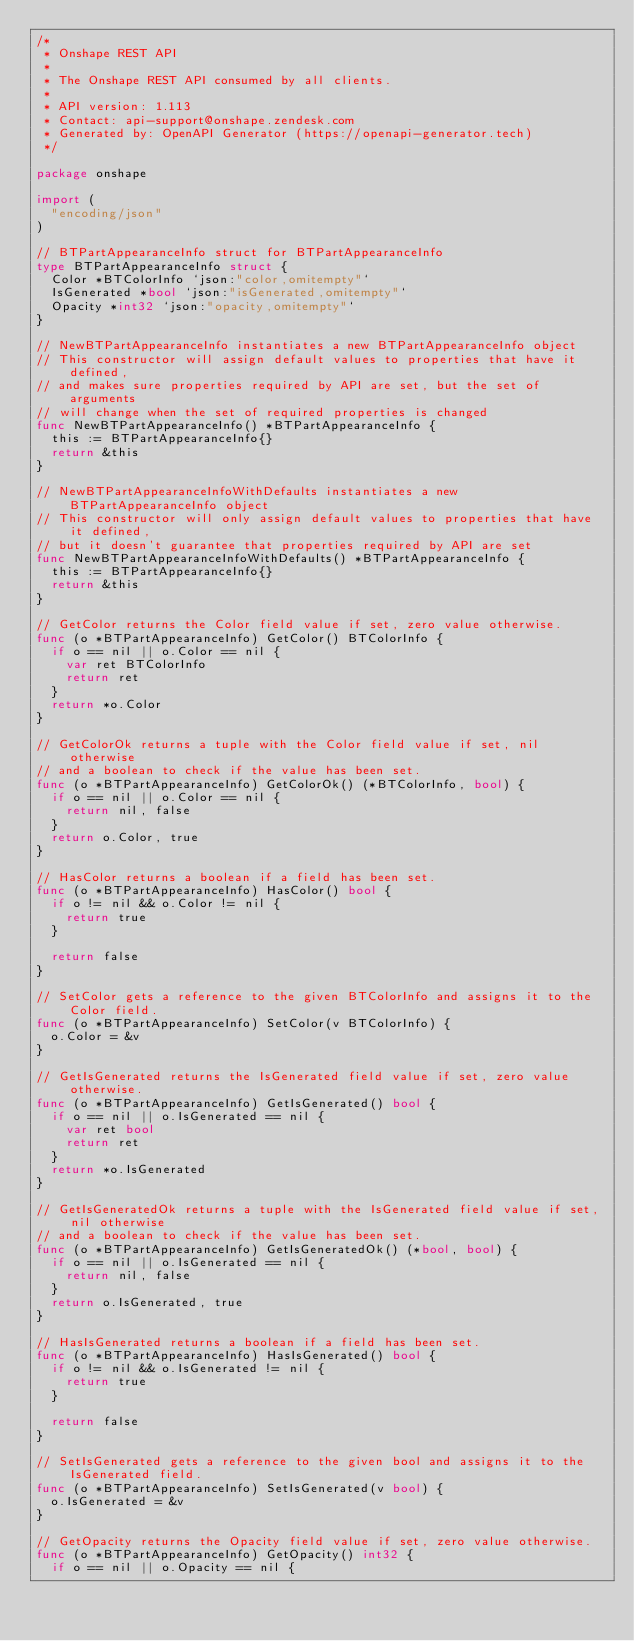<code> <loc_0><loc_0><loc_500><loc_500><_Go_>/*
 * Onshape REST API
 *
 * The Onshape REST API consumed by all clients.
 *
 * API version: 1.113
 * Contact: api-support@onshape.zendesk.com
 * Generated by: OpenAPI Generator (https://openapi-generator.tech)
 */

package onshape

import (
	"encoding/json"
)

// BTPartAppearanceInfo struct for BTPartAppearanceInfo
type BTPartAppearanceInfo struct {
	Color *BTColorInfo `json:"color,omitempty"`
	IsGenerated *bool `json:"isGenerated,omitempty"`
	Opacity *int32 `json:"opacity,omitempty"`
}

// NewBTPartAppearanceInfo instantiates a new BTPartAppearanceInfo object
// This constructor will assign default values to properties that have it defined,
// and makes sure properties required by API are set, but the set of arguments
// will change when the set of required properties is changed
func NewBTPartAppearanceInfo() *BTPartAppearanceInfo {
	this := BTPartAppearanceInfo{}
	return &this
}

// NewBTPartAppearanceInfoWithDefaults instantiates a new BTPartAppearanceInfo object
// This constructor will only assign default values to properties that have it defined,
// but it doesn't guarantee that properties required by API are set
func NewBTPartAppearanceInfoWithDefaults() *BTPartAppearanceInfo {
	this := BTPartAppearanceInfo{}
	return &this
}

// GetColor returns the Color field value if set, zero value otherwise.
func (o *BTPartAppearanceInfo) GetColor() BTColorInfo {
	if o == nil || o.Color == nil {
		var ret BTColorInfo
		return ret
	}
	return *o.Color
}

// GetColorOk returns a tuple with the Color field value if set, nil otherwise
// and a boolean to check if the value has been set.
func (o *BTPartAppearanceInfo) GetColorOk() (*BTColorInfo, bool) {
	if o == nil || o.Color == nil {
		return nil, false
	}
	return o.Color, true
}

// HasColor returns a boolean if a field has been set.
func (o *BTPartAppearanceInfo) HasColor() bool {
	if o != nil && o.Color != nil {
		return true
	}

	return false
}

// SetColor gets a reference to the given BTColorInfo and assigns it to the Color field.
func (o *BTPartAppearanceInfo) SetColor(v BTColorInfo) {
	o.Color = &v
}

// GetIsGenerated returns the IsGenerated field value if set, zero value otherwise.
func (o *BTPartAppearanceInfo) GetIsGenerated() bool {
	if o == nil || o.IsGenerated == nil {
		var ret bool
		return ret
	}
	return *o.IsGenerated
}

// GetIsGeneratedOk returns a tuple with the IsGenerated field value if set, nil otherwise
// and a boolean to check if the value has been set.
func (o *BTPartAppearanceInfo) GetIsGeneratedOk() (*bool, bool) {
	if o == nil || o.IsGenerated == nil {
		return nil, false
	}
	return o.IsGenerated, true
}

// HasIsGenerated returns a boolean if a field has been set.
func (o *BTPartAppearanceInfo) HasIsGenerated() bool {
	if o != nil && o.IsGenerated != nil {
		return true
	}

	return false
}

// SetIsGenerated gets a reference to the given bool and assigns it to the IsGenerated field.
func (o *BTPartAppearanceInfo) SetIsGenerated(v bool) {
	o.IsGenerated = &v
}

// GetOpacity returns the Opacity field value if set, zero value otherwise.
func (o *BTPartAppearanceInfo) GetOpacity() int32 {
	if o == nil || o.Opacity == nil {</code> 